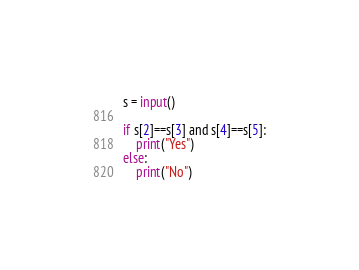Convert code to text. <code><loc_0><loc_0><loc_500><loc_500><_Python_>s = input()

if s[2]==s[3] and s[4]==s[5]:
    print("Yes")
else:
    print("No") </code> 